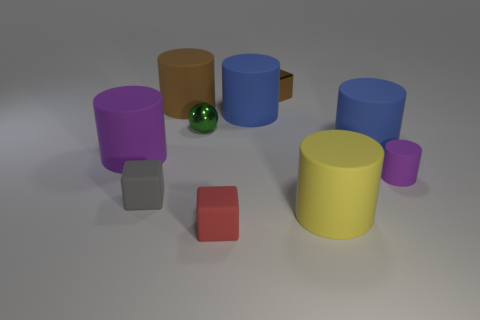Is the number of purple rubber cylinders on the right side of the tiny green ball greater than the number of matte cubes that are on the right side of the tiny purple thing?
Ensure brevity in your answer.  Yes. How many matte things are purple cylinders or small objects?
Keep it short and to the point. 4. There is a cylinder that is the same color as the tiny metal cube; what is it made of?
Your response must be concise. Rubber. Is the number of things behind the tiny purple thing less than the number of brown shiny blocks left of the small ball?
Your response must be concise. No. What number of objects are either cyan metallic cylinders or cubes that are behind the tiny purple object?
Make the answer very short. 1. What is the material of the green ball that is the same size as the brown metal block?
Offer a terse response. Metal. Are the tiny purple object and the yellow thing made of the same material?
Ensure brevity in your answer.  Yes. What is the color of the rubber thing that is both behind the green metal thing and right of the big brown rubber object?
Keep it short and to the point. Blue. There is a big matte cylinder that is to the left of the tiny gray matte block; does it have the same color as the tiny rubber cylinder?
Your response must be concise. Yes. What shape is the brown rubber thing that is the same size as the yellow thing?
Offer a terse response. Cylinder. 